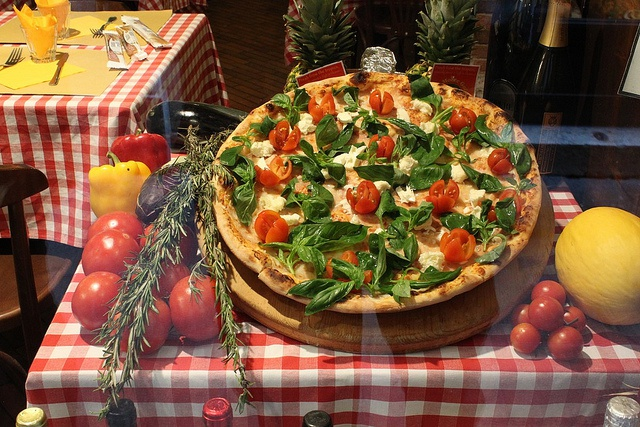Describe the objects in this image and their specific colors. I can see dining table in maroon, olive, black, and tan tones, pizza in maroon, darkgreen, black, tan, and brown tones, dining table in maroon, gold, and tan tones, chair in maroon, black, and brown tones, and chair in maroon, black, gray, and darkgreen tones in this image. 